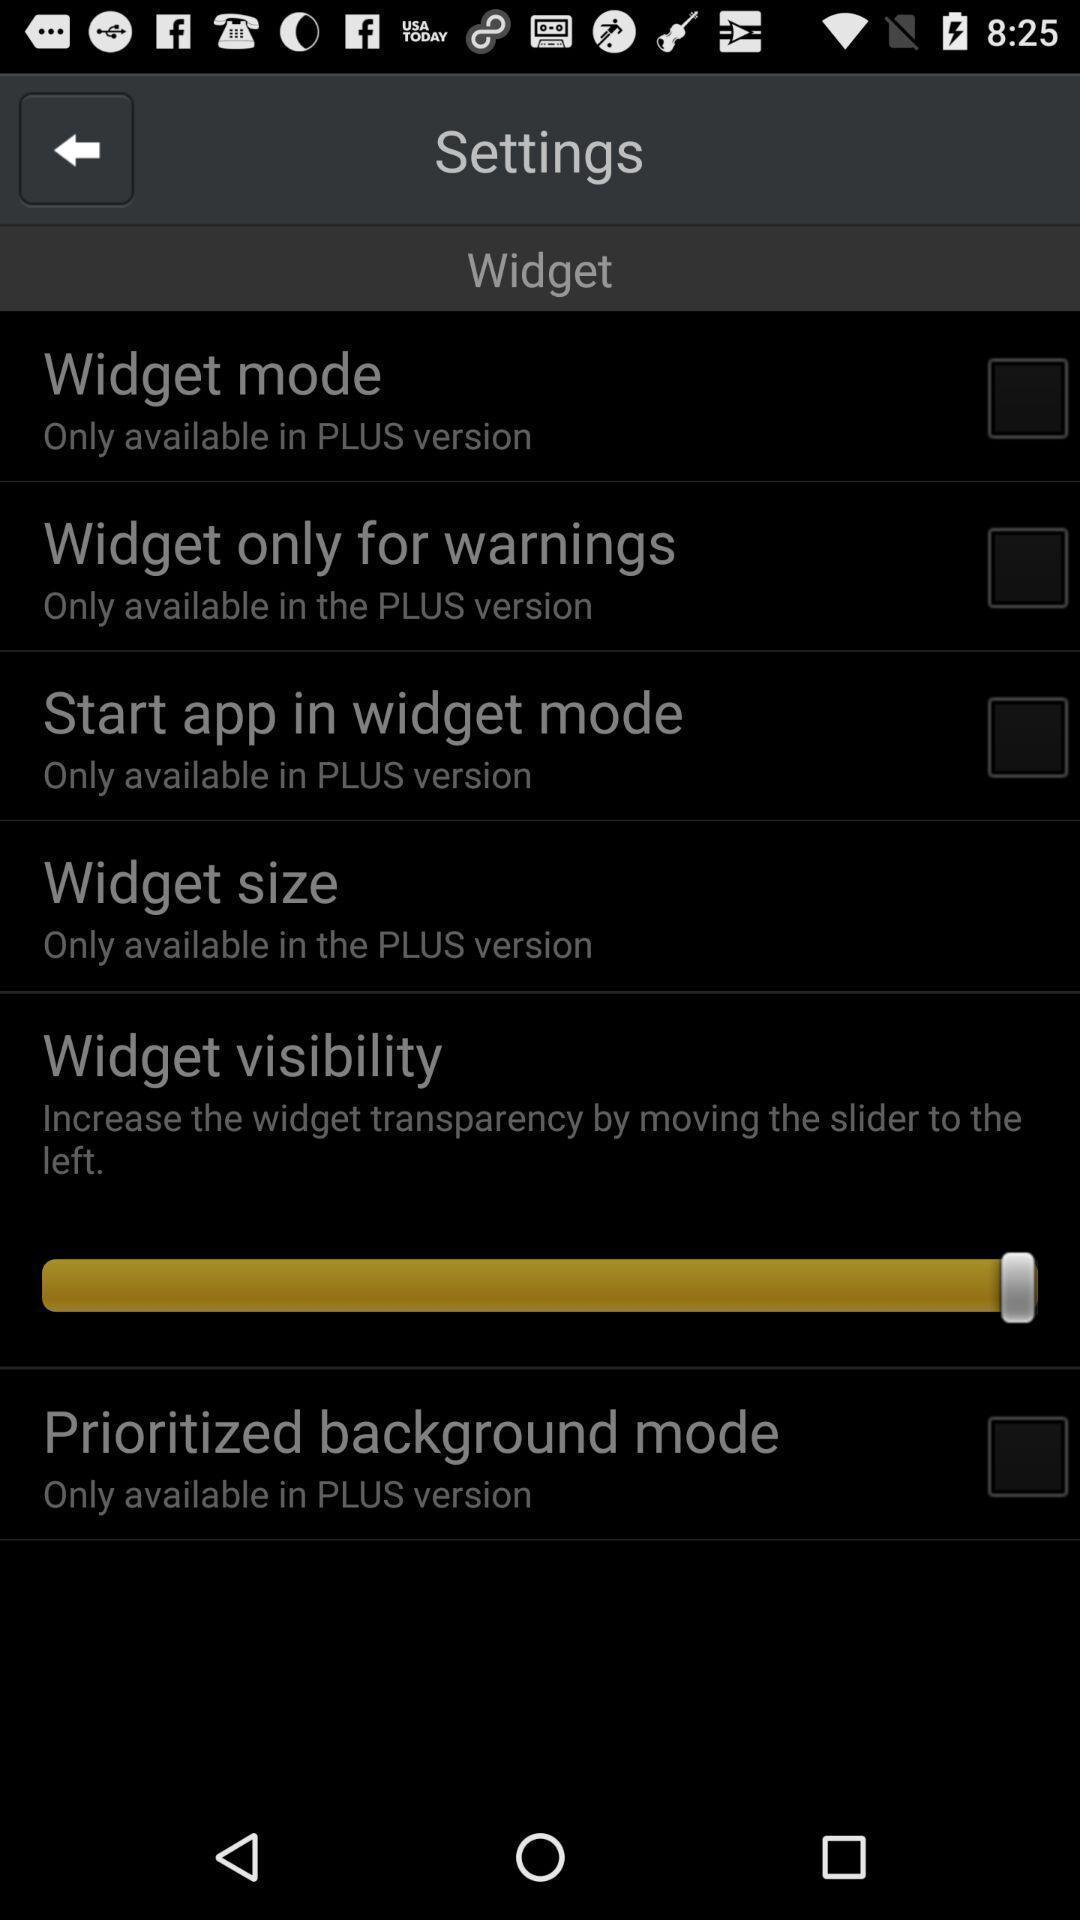Describe the key features of this screenshot. Settings page. 